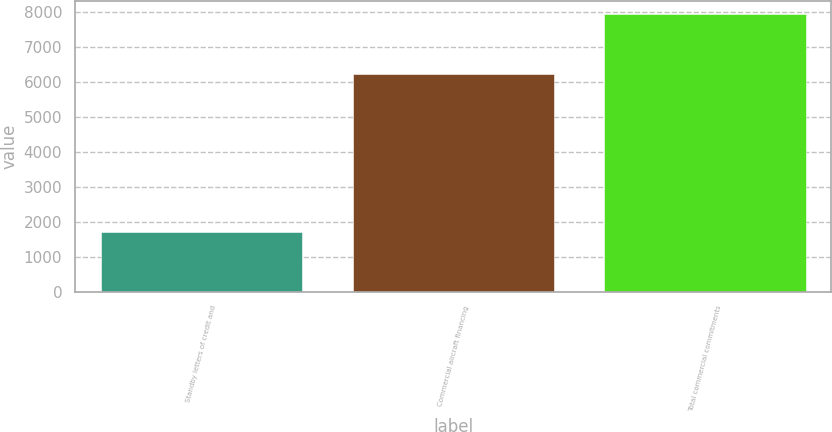<chart> <loc_0><loc_0><loc_500><loc_500><bar_chart><fcel>Standby letters of credit and<fcel>Commercial aircraft financing<fcel>Total commercial commitments<nl><fcel>1703<fcel>6216<fcel>7919<nl></chart> 